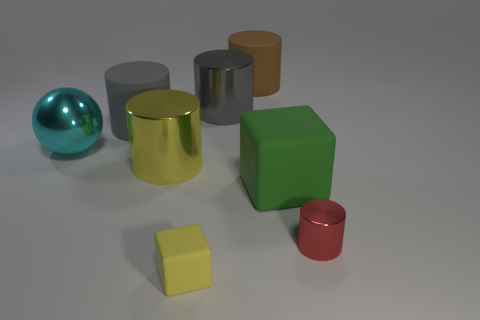Subtract 2 cylinders. How many cylinders are left? 3 Subtract all large brown cylinders. How many cylinders are left? 4 Subtract all yellow cylinders. How many cylinders are left? 4 Subtract all blue cylinders. Subtract all red spheres. How many cylinders are left? 5 Add 2 green objects. How many objects exist? 10 Subtract all balls. How many objects are left? 7 Add 2 small yellow matte balls. How many small yellow matte balls exist? 2 Subtract 2 gray cylinders. How many objects are left? 6 Subtract all large objects. Subtract all big brown matte cylinders. How many objects are left? 1 Add 6 yellow rubber objects. How many yellow rubber objects are left? 7 